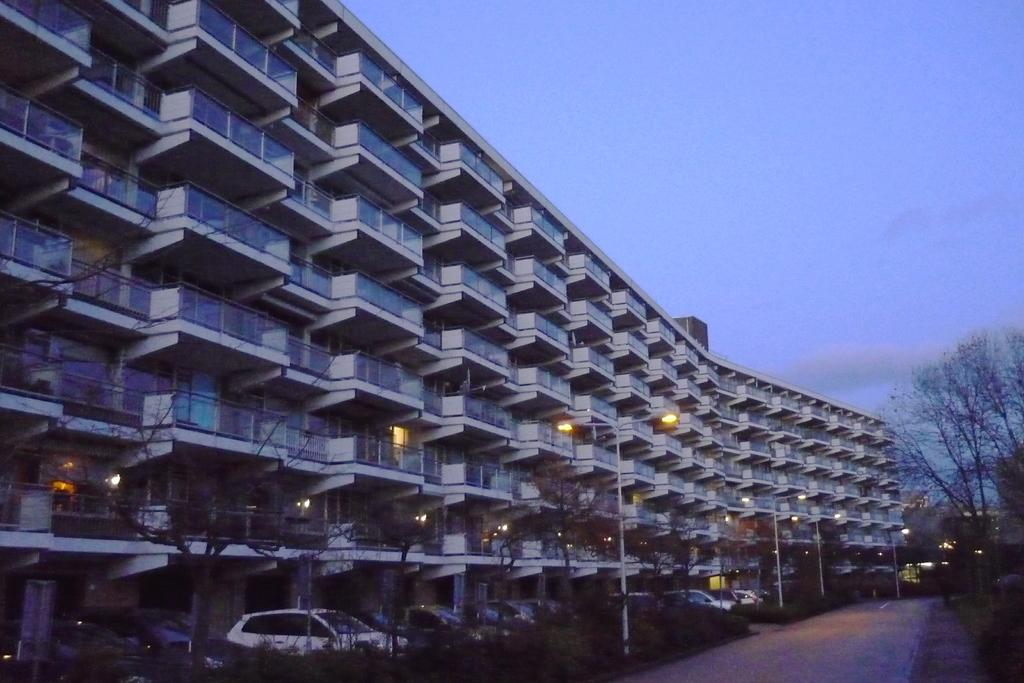What type of structure is visible in the image? There is a building in the image. What can be seen at the bottom of the image? Cars are parked at the bottom of the image. What type of vegetation is present in the image? There are plants in the image. Where are the trees located in the image? Trees are present to the right of the image. What is visible in the sky at the top of the image? Clouds are visible in the sky at the top of the image. What type of cap is the person wearing in the image? There is no person wearing a cap in the image. What shoes is the person wearing in the image? There is no person present in the image, so we cannot determine what shoes they might be wearing. 